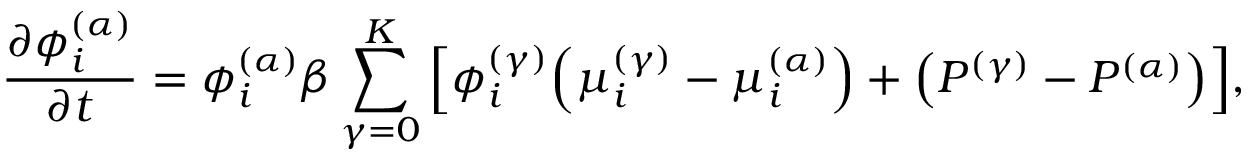<formula> <loc_0><loc_0><loc_500><loc_500>\frac { \partial \phi _ { i } ^ { ( \alpha ) } } { \partial t } = \phi _ { i } ^ { ( \alpha ) } \beta \sum _ { \gamma = 0 } ^ { K } \left [ \phi _ { i } ^ { ( \gamma ) } \, \left ( \mu _ { i } ^ { ( \gamma ) } - \mu _ { i } ^ { ( \alpha ) } \right ) + \left ( P ^ { ( \gamma ) } - P ^ { ( \alpha ) } \right ) \right ] \, ,</formula> 